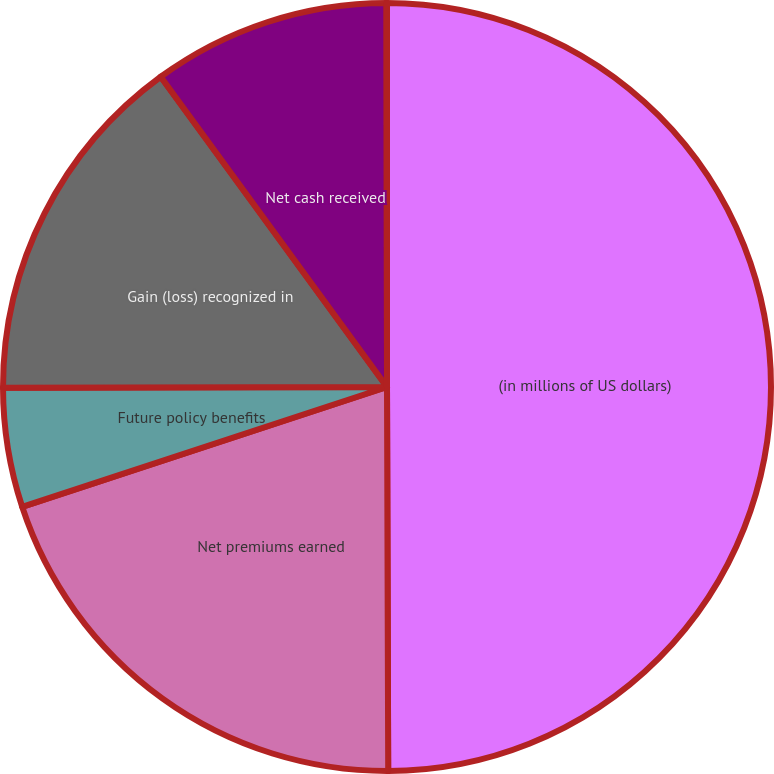Convert chart to OTSL. <chart><loc_0><loc_0><loc_500><loc_500><pie_chart><fcel>(in millions of US dollars)<fcel>Net premiums earned<fcel>Future policy benefits<fcel>Gain (loss) recognized in<fcel>Net cash received<fcel>Net decrease (increase) in<nl><fcel>49.95%<fcel>20.0%<fcel>5.02%<fcel>15.0%<fcel>10.01%<fcel>0.02%<nl></chart> 